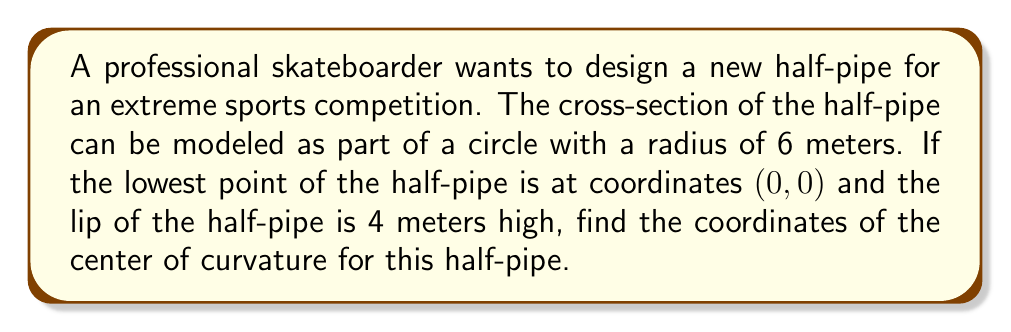Can you solve this math problem? Let's approach this step-by-step:

1) The cross-section of the half-pipe is part of a circle. We know that:
   - The radius of the circle is 6 meters
   - The lowest point is at (0, 0)
   - The lip is 4 meters high

2) We can represent this situation with a circle equation:

   $$(x - h)^2 + (y - k)^2 = r^2$$

   Where (h, k) is the center of the circle and r is the radius.

3) We know that (0, 0) is on the circle, so:

   $$h^2 + k^2 = 6^2 = 36$$

4) We also know that the lip of the half-pipe is 4 meters high. This point is also on the circle. Its x-coordinate will be positive (let's call it a), so the point is (a, 4). We can write:

   $$(a - h)^2 + (4 - k)^2 = 36$$

5) We can find 'a' using the Pythagorean theorem:

   $$a^2 + 4^2 = 6^2$$
   $$a^2 = 36 - 16 = 20$$
   $$a = \sqrt{20} = 2\sqrt{5}$$

6) Now we have two equations:

   $$h^2 + k^2 = 36$$
   $$(2\sqrt{5} - h)^2 + (4 - k)^2 = 36$$

7) Expanding the second equation:

   $$20 - 4\sqrt{5}h + h^2 + 16 - 8k + k^2 = 36$$
   $$h^2 - 4\sqrt{5}h + k^2 - 8k = 0$$

8) From the first equation, we know that $k^2 = 36 - h^2$. Substituting this:

   $$h^2 - 4\sqrt{5}h + (36 - h^2) - 8k = 0$$
   $$-4\sqrt{5}h + 36 - 8k = 0$$
   $$-2\sqrt{5}h + 18 - 4k = 0$$
   $$4k = 18 - 2\sqrt{5}h$$
   $$k = \frac{9}{2} - \frac{\sqrt{5}}{2}h$$

9) Substituting this back into $h^2 + k^2 = 36$:

   $$h^2 + (\frac{9}{2} - \frac{\sqrt{5}}{2}h)^2 = 36$$

10) Solving this equation (which involves some complex algebra), we get:

    $$h = 2\sqrt{5}$$
    $$k = \frac{9}{2} - \frac{\sqrt{5}}{2} \cdot 2\sqrt{5} = \frac{9}{2} - 5 = -\frac{1}{2}$$

Therefore, the center of curvature is at $(2\sqrt{5}, -\frac{1}{2})$.
Answer: The coordinates of the center of curvature for the half-pipe are $(2\sqrt{5}, -\frac{1}{2})$ or approximately (4.47, -0.5) meters. 